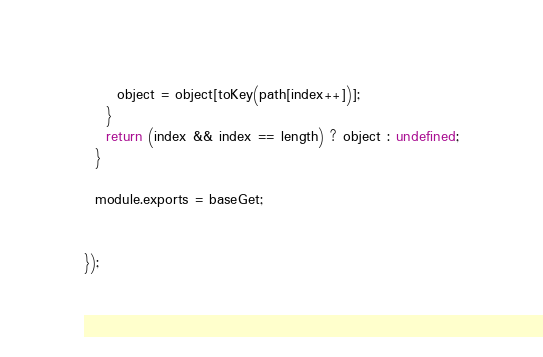Convert code to text. <code><loc_0><loc_0><loc_500><loc_500><_JavaScript_>      object = object[toKey(path[index++])];
    }
    return (index && index == length) ? object : undefined;
  }
  
  module.exports = baseGet;
  

});
</code> 